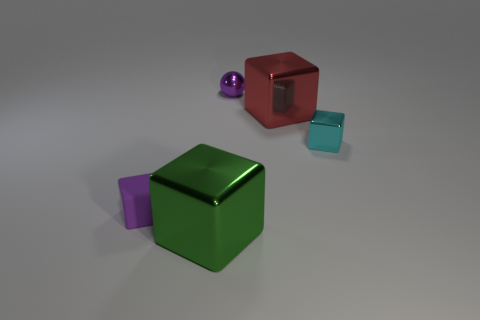How many objects are red matte blocks or small blocks that are on the right side of the metal ball? In the image, there is only one red matte block. Regarding the small blocks on the right side of the metal ball, there are two small blocks fitting that description. 